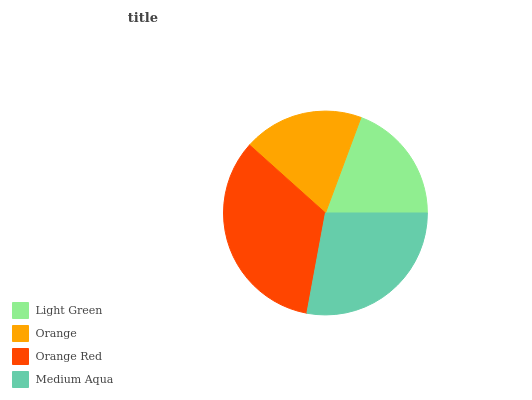Is Orange the minimum?
Answer yes or no. Yes. Is Orange Red the maximum?
Answer yes or no. Yes. Is Orange Red the minimum?
Answer yes or no. No. Is Orange the maximum?
Answer yes or no. No. Is Orange Red greater than Orange?
Answer yes or no. Yes. Is Orange less than Orange Red?
Answer yes or no. Yes. Is Orange greater than Orange Red?
Answer yes or no. No. Is Orange Red less than Orange?
Answer yes or no. No. Is Medium Aqua the high median?
Answer yes or no. Yes. Is Light Green the low median?
Answer yes or no. Yes. Is Orange Red the high median?
Answer yes or no. No. Is Orange Red the low median?
Answer yes or no. No. 